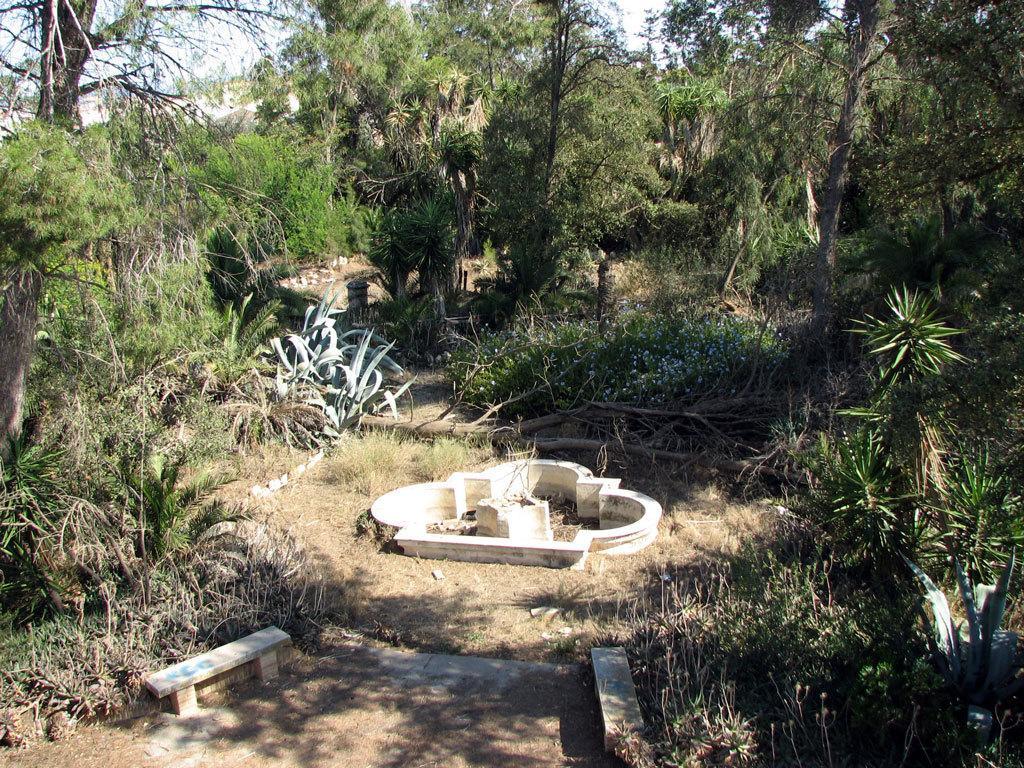Describe this image in one or two sentences. In this picture there are trees. In the middle of the image it looks like a fountain and there are benches. At the top there is sky. At the bottom there is ground and there are plants. 